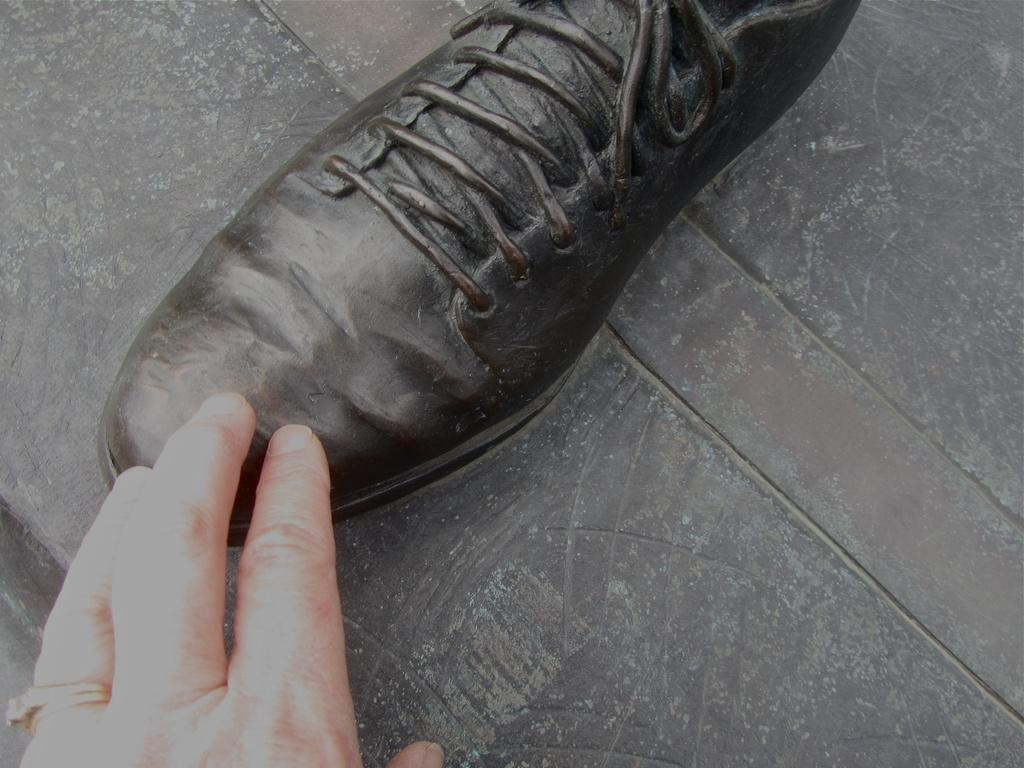What is the main subject of the image? There is a depiction of a shoe in the image. What else can be seen in the image besides the shoe? There is a hand of a person in the image. Can you describe any accessories worn by the person in the image? There is a ring on the person's finger in the image. Can you describe the seashore in the image? There is no seashore present in the image; it features a shoe, a hand, and a ring. How many boys are visible in the image? There is no boy present in the image; it features a shoe, a hand, and a ring. 